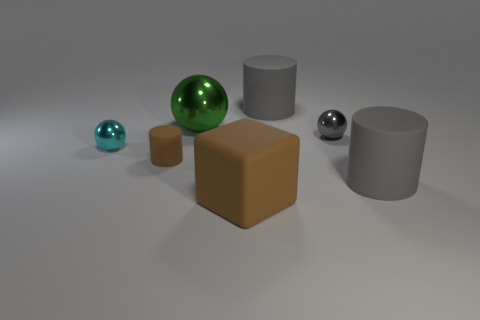Can you describe the texture of the surface these objects are resting on? The surface appears smooth with a subtle matte sheen, consistent with a typical floor used in 3D renderings or a fine-textured industrial material. 